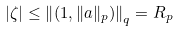Convert formula to latex. <formula><loc_0><loc_0><loc_500><loc_500>| \zeta | \leq \left \| \left ( 1 , \| a \| _ { p } \right ) \right \| _ { q } = R _ { p }</formula> 